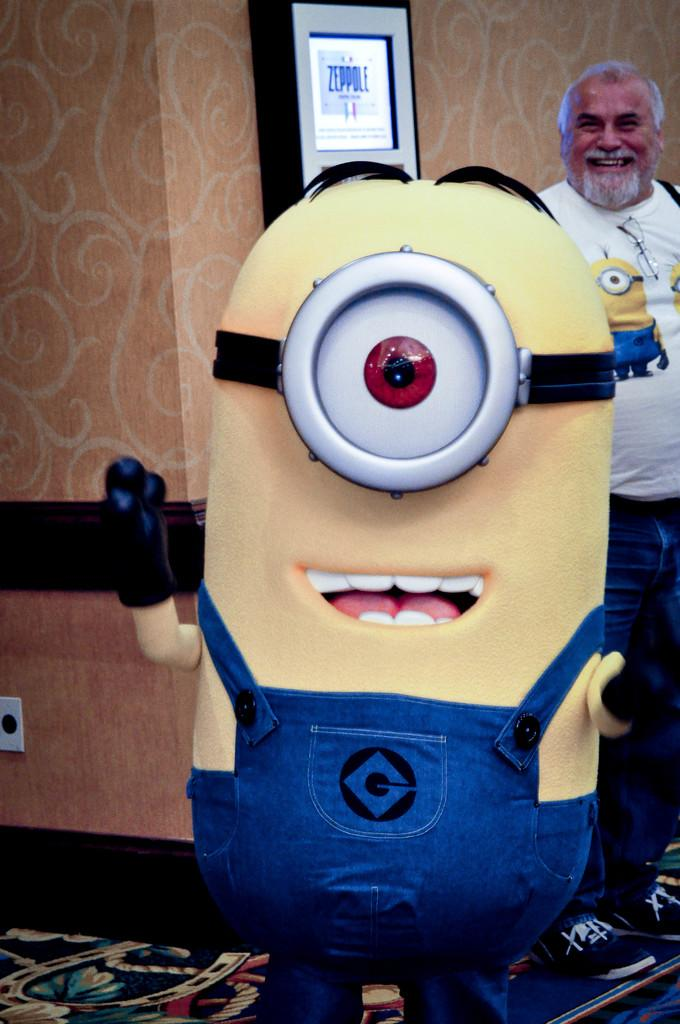What character can be seen in the image? There is a minion in the image. Who else is present in the image? There is a person in the image. What is on the ground in the image? The ground is visible in the image with a mat. What can be seen on the wall in the image? There is a wall in the image with some objects. What topic are the minion and the person discussing in the image? The image does not show the minion and the person talking or discussing any topic. 